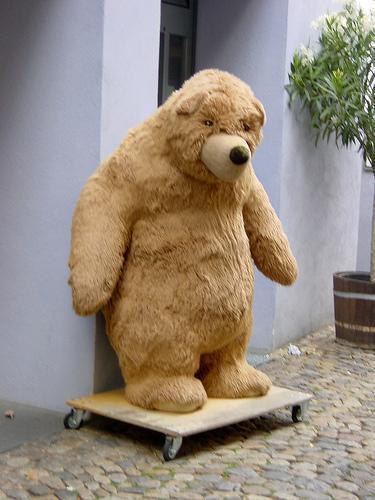How many bears are there?
Give a very brief answer. 1. 